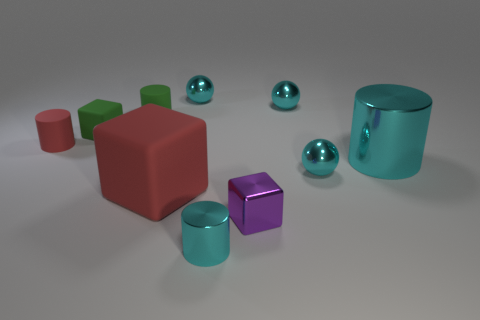Do the tiny metal cylinder and the metal sphere that is in front of the small red thing have the same color?
Give a very brief answer. Yes. There is a rubber block that is behind the rubber object that is on the left side of the green cube; what size is it?
Your answer should be very brief. Small. How many things are large cyan cylinders or tiny cyan objects that are to the right of the purple cube?
Your response must be concise. 3. There is a red object behind the large red thing; does it have the same shape as the large red object?
Give a very brief answer. No. There is a small block that is left of the small matte cylinder behind the tiny green matte cube; what number of cyan shiny spheres are in front of it?
Provide a short and direct response. 1. Are there any other things that are the same shape as the large cyan thing?
Your answer should be very brief. Yes. How many things are big cyan metallic cubes or metallic things?
Give a very brief answer. 6. Does the big cyan thing have the same shape as the red matte thing that is left of the green matte cylinder?
Offer a very short reply. Yes. There is a large red rubber object that is to the right of the red rubber cylinder; what is its shape?
Provide a short and direct response. Cube. Is the shape of the big metallic object the same as the tiny red thing?
Give a very brief answer. Yes. 